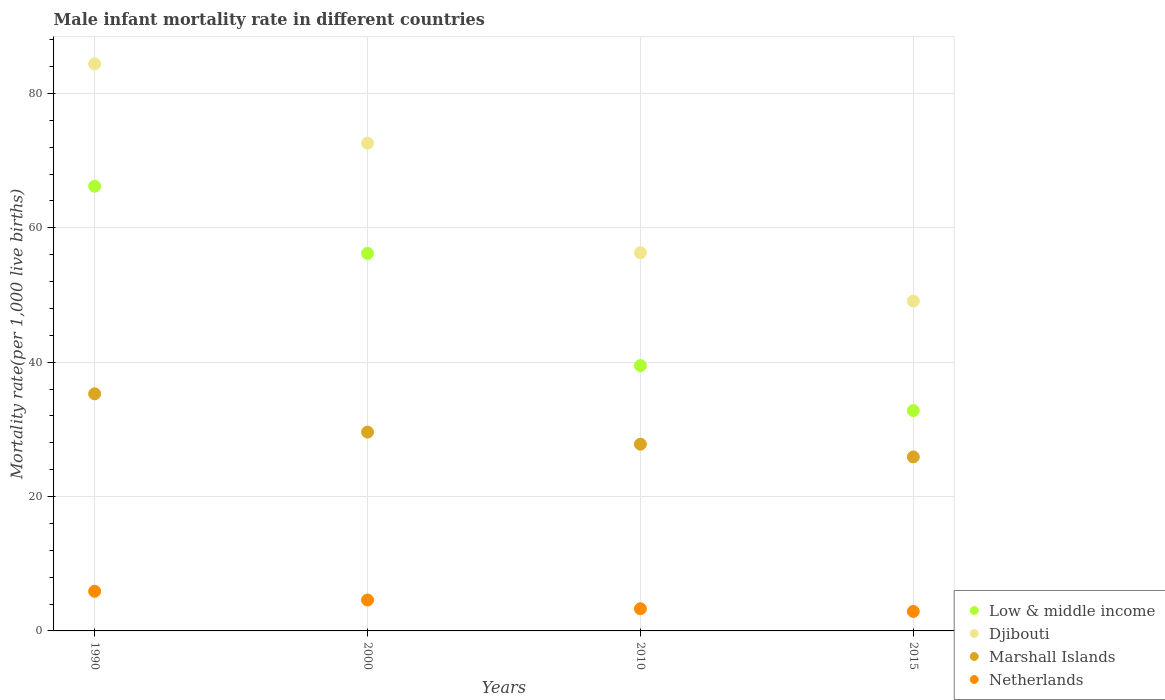How many different coloured dotlines are there?
Give a very brief answer. 4. Is the number of dotlines equal to the number of legend labels?
Offer a very short reply. Yes. What is the male infant mortality rate in Djibouti in 1990?
Offer a very short reply. 84.4. Across all years, what is the maximum male infant mortality rate in Djibouti?
Your answer should be very brief. 84.4. Across all years, what is the minimum male infant mortality rate in Marshall Islands?
Your response must be concise. 25.9. In which year was the male infant mortality rate in Low & middle income maximum?
Ensure brevity in your answer.  1990. In which year was the male infant mortality rate in Low & middle income minimum?
Offer a very short reply. 2015. What is the difference between the male infant mortality rate in Netherlands in 1990 and that in 2000?
Your answer should be compact. 1.3. What is the difference between the male infant mortality rate in Marshall Islands in 1990 and the male infant mortality rate in Netherlands in 2000?
Ensure brevity in your answer.  30.7. What is the average male infant mortality rate in Djibouti per year?
Give a very brief answer. 65.6. In the year 2010, what is the difference between the male infant mortality rate in Marshall Islands and male infant mortality rate in Netherlands?
Your response must be concise. 24.5. What is the ratio of the male infant mortality rate in Low & middle income in 2010 to that in 2015?
Make the answer very short. 1.2. Is the male infant mortality rate in Low & middle income in 1990 less than that in 2010?
Your answer should be very brief. No. Is the difference between the male infant mortality rate in Marshall Islands in 1990 and 2010 greater than the difference between the male infant mortality rate in Netherlands in 1990 and 2010?
Your answer should be very brief. Yes. What is the difference between the highest and the second highest male infant mortality rate in Netherlands?
Offer a terse response. 1.3. What is the difference between the highest and the lowest male infant mortality rate in Low & middle income?
Ensure brevity in your answer.  33.4. Is it the case that in every year, the sum of the male infant mortality rate in Netherlands and male infant mortality rate in Low & middle income  is greater than the sum of male infant mortality rate in Marshall Islands and male infant mortality rate in Djibouti?
Your answer should be compact. Yes. Is it the case that in every year, the sum of the male infant mortality rate in Netherlands and male infant mortality rate in Low & middle income  is greater than the male infant mortality rate in Marshall Islands?
Make the answer very short. Yes. Does the male infant mortality rate in Djibouti monotonically increase over the years?
Provide a short and direct response. No. How many dotlines are there?
Give a very brief answer. 4. What is the difference between two consecutive major ticks on the Y-axis?
Provide a succinct answer. 20. Are the values on the major ticks of Y-axis written in scientific E-notation?
Offer a very short reply. No. Does the graph contain any zero values?
Make the answer very short. No. Where does the legend appear in the graph?
Give a very brief answer. Bottom right. How many legend labels are there?
Make the answer very short. 4. How are the legend labels stacked?
Offer a very short reply. Vertical. What is the title of the graph?
Make the answer very short. Male infant mortality rate in different countries. What is the label or title of the X-axis?
Your answer should be very brief. Years. What is the label or title of the Y-axis?
Keep it short and to the point. Mortality rate(per 1,0 live births). What is the Mortality rate(per 1,000 live births) in Low & middle income in 1990?
Offer a terse response. 66.2. What is the Mortality rate(per 1,000 live births) of Djibouti in 1990?
Offer a terse response. 84.4. What is the Mortality rate(per 1,000 live births) of Marshall Islands in 1990?
Your answer should be compact. 35.3. What is the Mortality rate(per 1,000 live births) in Netherlands in 1990?
Provide a succinct answer. 5.9. What is the Mortality rate(per 1,000 live births) of Low & middle income in 2000?
Give a very brief answer. 56.2. What is the Mortality rate(per 1,000 live births) in Djibouti in 2000?
Your answer should be compact. 72.6. What is the Mortality rate(per 1,000 live births) of Marshall Islands in 2000?
Offer a very short reply. 29.6. What is the Mortality rate(per 1,000 live births) of Netherlands in 2000?
Keep it short and to the point. 4.6. What is the Mortality rate(per 1,000 live births) of Low & middle income in 2010?
Offer a very short reply. 39.5. What is the Mortality rate(per 1,000 live births) of Djibouti in 2010?
Provide a succinct answer. 56.3. What is the Mortality rate(per 1,000 live births) in Marshall Islands in 2010?
Provide a succinct answer. 27.8. What is the Mortality rate(per 1,000 live births) in Netherlands in 2010?
Keep it short and to the point. 3.3. What is the Mortality rate(per 1,000 live births) of Low & middle income in 2015?
Offer a very short reply. 32.8. What is the Mortality rate(per 1,000 live births) of Djibouti in 2015?
Make the answer very short. 49.1. What is the Mortality rate(per 1,000 live births) in Marshall Islands in 2015?
Your answer should be compact. 25.9. Across all years, what is the maximum Mortality rate(per 1,000 live births) in Low & middle income?
Your answer should be very brief. 66.2. Across all years, what is the maximum Mortality rate(per 1,000 live births) of Djibouti?
Your answer should be compact. 84.4. Across all years, what is the maximum Mortality rate(per 1,000 live births) in Marshall Islands?
Your answer should be very brief. 35.3. Across all years, what is the maximum Mortality rate(per 1,000 live births) of Netherlands?
Your answer should be compact. 5.9. Across all years, what is the minimum Mortality rate(per 1,000 live births) in Low & middle income?
Offer a very short reply. 32.8. Across all years, what is the minimum Mortality rate(per 1,000 live births) of Djibouti?
Your answer should be compact. 49.1. Across all years, what is the minimum Mortality rate(per 1,000 live births) of Marshall Islands?
Make the answer very short. 25.9. Across all years, what is the minimum Mortality rate(per 1,000 live births) of Netherlands?
Your answer should be compact. 2.9. What is the total Mortality rate(per 1,000 live births) of Low & middle income in the graph?
Offer a very short reply. 194.7. What is the total Mortality rate(per 1,000 live births) of Djibouti in the graph?
Your response must be concise. 262.4. What is the total Mortality rate(per 1,000 live births) of Marshall Islands in the graph?
Provide a short and direct response. 118.6. What is the total Mortality rate(per 1,000 live births) of Netherlands in the graph?
Your answer should be very brief. 16.7. What is the difference between the Mortality rate(per 1,000 live births) in Djibouti in 1990 and that in 2000?
Give a very brief answer. 11.8. What is the difference between the Mortality rate(per 1,000 live births) of Low & middle income in 1990 and that in 2010?
Offer a terse response. 26.7. What is the difference between the Mortality rate(per 1,000 live births) in Djibouti in 1990 and that in 2010?
Provide a succinct answer. 28.1. What is the difference between the Mortality rate(per 1,000 live births) in Marshall Islands in 1990 and that in 2010?
Ensure brevity in your answer.  7.5. What is the difference between the Mortality rate(per 1,000 live births) in Low & middle income in 1990 and that in 2015?
Keep it short and to the point. 33.4. What is the difference between the Mortality rate(per 1,000 live births) of Djibouti in 1990 and that in 2015?
Provide a succinct answer. 35.3. What is the difference between the Mortality rate(per 1,000 live births) of Marshall Islands in 1990 and that in 2015?
Provide a short and direct response. 9.4. What is the difference between the Mortality rate(per 1,000 live births) of Netherlands in 1990 and that in 2015?
Give a very brief answer. 3. What is the difference between the Mortality rate(per 1,000 live births) of Marshall Islands in 2000 and that in 2010?
Your answer should be very brief. 1.8. What is the difference between the Mortality rate(per 1,000 live births) of Low & middle income in 2000 and that in 2015?
Offer a terse response. 23.4. What is the difference between the Mortality rate(per 1,000 live births) of Djibouti in 2000 and that in 2015?
Your answer should be compact. 23.5. What is the difference between the Mortality rate(per 1,000 live births) in Low & middle income in 2010 and that in 2015?
Keep it short and to the point. 6.7. What is the difference between the Mortality rate(per 1,000 live births) of Djibouti in 2010 and that in 2015?
Give a very brief answer. 7.2. What is the difference between the Mortality rate(per 1,000 live births) in Netherlands in 2010 and that in 2015?
Offer a very short reply. 0.4. What is the difference between the Mortality rate(per 1,000 live births) of Low & middle income in 1990 and the Mortality rate(per 1,000 live births) of Djibouti in 2000?
Give a very brief answer. -6.4. What is the difference between the Mortality rate(per 1,000 live births) of Low & middle income in 1990 and the Mortality rate(per 1,000 live births) of Marshall Islands in 2000?
Keep it short and to the point. 36.6. What is the difference between the Mortality rate(per 1,000 live births) of Low & middle income in 1990 and the Mortality rate(per 1,000 live births) of Netherlands in 2000?
Give a very brief answer. 61.6. What is the difference between the Mortality rate(per 1,000 live births) of Djibouti in 1990 and the Mortality rate(per 1,000 live births) of Marshall Islands in 2000?
Make the answer very short. 54.8. What is the difference between the Mortality rate(per 1,000 live births) of Djibouti in 1990 and the Mortality rate(per 1,000 live births) of Netherlands in 2000?
Make the answer very short. 79.8. What is the difference between the Mortality rate(per 1,000 live births) of Marshall Islands in 1990 and the Mortality rate(per 1,000 live births) of Netherlands in 2000?
Keep it short and to the point. 30.7. What is the difference between the Mortality rate(per 1,000 live births) in Low & middle income in 1990 and the Mortality rate(per 1,000 live births) in Marshall Islands in 2010?
Make the answer very short. 38.4. What is the difference between the Mortality rate(per 1,000 live births) of Low & middle income in 1990 and the Mortality rate(per 1,000 live births) of Netherlands in 2010?
Your answer should be very brief. 62.9. What is the difference between the Mortality rate(per 1,000 live births) in Djibouti in 1990 and the Mortality rate(per 1,000 live births) in Marshall Islands in 2010?
Keep it short and to the point. 56.6. What is the difference between the Mortality rate(per 1,000 live births) in Djibouti in 1990 and the Mortality rate(per 1,000 live births) in Netherlands in 2010?
Provide a short and direct response. 81.1. What is the difference between the Mortality rate(per 1,000 live births) in Low & middle income in 1990 and the Mortality rate(per 1,000 live births) in Marshall Islands in 2015?
Provide a succinct answer. 40.3. What is the difference between the Mortality rate(per 1,000 live births) of Low & middle income in 1990 and the Mortality rate(per 1,000 live births) of Netherlands in 2015?
Your response must be concise. 63.3. What is the difference between the Mortality rate(per 1,000 live births) of Djibouti in 1990 and the Mortality rate(per 1,000 live births) of Marshall Islands in 2015?
Give a very brief answer. 58.5. What is the difference between the Mortality rate(per 1,000 live births) in Djibouti in 1990 and the Mortality rate(per 1,000 live births) in Netherlands in 2015?
Give a very brief answer. 81.5. What is the difference between the Mortality rate(per 1,000 live births) in Marshall Islands in 1990 and the Mortality rate(per 1,000 live births) in Netherlands in 2015?
Keep it short and to the point. 32.4. What is the difference between the Mortality rate(per 1,000 live births) in Low & middle income in 2000 and the Mortality rate(per 1,000 live births) in Marshall Islands in 2010?
Provide a succinct answer. 28.4. What is the difference between the Mortality rate(per 1,000 live births) of Low & middle income in 2000 and the Mortality rate(per 1,000 live births) of Netherlands in 2010?
Ensure brevity in your answer.  52.9. What is the difference between the Mortality rate(per 1,000 live births) of Djibouti in 2000 and the Mortality rate(per 1,000 live births) of Marshall Islands in 2010?
Offer a very short reply. 44.8. What is the difference between the Mortality rate(per 1,000 live births) of Djibouti in 2000 and the Mortality rate(per 1,000 live births) of Netherlands in 2010?
Your answer should be compact. 69.3. What is the difference between the Mortality rate(per 1,000 live births) in Marshall Islands in 2000 and the Mortality rate(per 1,000 live births) in Netherlands in 2010?
Ensure brevity in your answer.  26.3. What is the difference between the Mortality rate(per 1,000 live births) of Low & middle income in 2000 and the Mortality rate(per 1,000 live births) of Marshall Islands in 2015?
Keep it short and to the point. 30.3. What is the difference between the Mortality rate(per 1,000 live births) in Low & middle income in 2000 and the Mortality rate(per 1,000 live births) in Netherlands in 2015?
Keep it short and to the point. 53.3. What is the difference between the Mortality rate(per 1,000 live births) of Djibouti in 2000 and the Mortality rate(per 1,000 live births) of Marshall Islands in 2015?
Provide a short and direct response. 46.7. What is the difference between the Mortality rate(per 1,000 live births) of Djibouti in 2000 and the Mortality rate(per 1,000 live births) of Netherlands in 2015?
Give a very brief answer. 69.7. What is the difference between the Mortality rate(per 1,000 live births) in Marshall Islands in 2000 and the Mortality rate(per 1,000 live births) in Netherlands in 2015?
Keep it short and to the point. 26.7. What is the difference between the Mortality rate(per 1,000 live births) in Low & middle income in 2010 and the Mortality rate(per 1,000 live births) in Djibouti in 2015?
Make the answer very short. -9.6. What is the difference between the Mortality rate(per 1,000 live births) in Low & middle income in 2010 and the Mortality rate(per 1,000 live births) in Netherlands in 2015?
Provide a short and direct response. 36.6. What is the difference between the Mortality rate(per 1,000 live births) of Djibouti in 2010 and the Mortality rate(per 1,000 live births) of Marshall Islands in 2015?
Your answer should be compact. 30.4. What is the difference between the Mortality rate(per 1,000 live births) of Djibouti in 2010 and the Mortality rate(per 1,000 live births) of Netherlands in 2015?
Offer a terse response. 53.4. What is the difference between the Mortality rate(per 1,000 live births) in Marshall Islands in 2010 and the Mortality rate(per 1,000 live births) in Netherlands in 2015?
Provide a short and direct response. 24.9. What is the average Mortality rate(per 1,000 live births) in Low & middle income per year?
Ensure brevity in your answer.  48.67. What is the average Mortality rate(per 1,000 live births) of Djibouti per year?
Offer a terse response. 65.6. What is the average Mortality rate(per 1,000 live births) of Marshall Islands per year?
Offer a very short reply. 29.65. What is the average Mortality rate(per 1,000 live births) in Netherlands per year?
Provide a succinct answer. 4.17. In the year 1990, what is the difference between the Mortality rate(per 1,000 live births) in Low & middle income and Mortality rate(per 1,000 live births) in Djibouti?
Make the answer very short. -18.2. In the year 1990, what is the difference between the Mortality rate(per 1,000 live births) in Low & middle income and Mortality rate(per 1,000 live births) in Marshall Islands?
Ensure brevity in your answer.  30.9. In the year 1990, what is the difference between the Mortality rate(per 1,000 live births) of Low & middle income and Mortality rate(per 1,000 live births) of Netherlands?
Your answer should be very brief. 60.3. In the year 1990, what is the difference between the Mortality rate(per 1,000 live births) of Djibouti and Mortality rate(per 1,000 live births) of Marshall Islands?
Your answer should be compact. 49.1. In the year 1990, what is the difference between the Mortality rate(per 1,000 live births) in Djibouti and Mortality rate(per 1,000 live births) in Netherlands?
Provide a short and direct response. 78.5. In the year 1990, what is the difference between the Mortality rate(per 1,000 live births) of Marshall Islands and Mortality rate(per 1,000 live births) of Netherlands?
Offer a terse response. 29.4. In the year 2000, what is the difference between the Mortality rate(per 1,000 live births) of Low & middle income and Mortality rate(per 1,000 live births) of Djibouti?
Provide a succinct answer. -16.4. In the year 2000, what is the difference between the Mortality rate(per 1,000 live births) in Low & middle income and Mortality rate(per 1,000 live births) in Marshall Islands?
Give a very brief answer. 26.6. In the year 2000, what is the difference between the Mortality rate(per 1,000 live births) of Low & middle income and Mortality rate(per 1,000 live births) of Netherlands?
Make the answer very short. 51.6. In the year 2000, what is the difference between the Mortality rate(per 1,000 live births) of Djibouti and Mortality rate(per 1,000 live births) of Netherlands?
Offer a terse response. 68. In the year 2000, what is the difference between the Mortality rate(per 1,000 live births) in Marshall Islands and Mortality rate(per 1,000 live births) in Netherlands?
Ensure brevity in your answer.  25. In the year 2010, what is the difference between the Mortality rate(per 1,000 live births) of Low & middle income and Mortality rate(per 1,000 live births) of Djibouti?
Keep it short and to the point. -16.8. In the year 2010, what is the difference between the Mortality rate(per 1,000 live births) in Low & middle income and Mortality rate(per 1,000 live births) in Marshall Islands?
Keep it short and to the point. 11.7. In the year 2010, what is the difference between the Mortality rate(per 1,000 live births) in Low & middle income and Mortality rate(per 1,000 live births) in Netherlands?
Give a very brief answer. 36.2. In the year 2010, what is the difference between the Mortality rate(per 1,000 live births) of Djibouti and Mortality rate(per 1,000 live births) of Marshall Islands?
Provide a short and direct response. 28.5. In the year 2010, what is the difference between the Mortality rate(per 1,000 live births) of Djibouti and Mortality rate(per 1,000 live births) of Netherlands?
Keep it short and to the point. 53. In the year 2015, what is the difference between the Mortality rate(per 1,000 live births) in Low & middle income and Mortality rate(per 1,000 live births) in Djibouti?
Your answer should be compact. -16.3. In the year 2015, what is the difference between the Mortality rate(per 1,000 live births) of Low & middle income and Mortality rate(per 1,000 live births) of Netherlands?
Your response must be concise. 29.9. In the year 2015, what is the difference between the Mortality rate(per 1,000 live births) in Djibouti and Mortality rate(per 1,000 live births) in Marshall Islands?
Your answer should be compact. 23.2. In the year 2015, what is the difference between the Mortality rate(per 1,000 live births) of Djibouti and Mortality rate(per 1,000 live births) of Netherlands?
Your answer should be very brief. 46.2. What is the ratio of the Mortality rate(per 1,000 live births) of Low & middle income in 1990 to that in 2000?
Ensure brevity in your answer.  1.18. What is the ratio of the Mortality rate(per 1,000 live births) of Djibouti in 1990 to that in 2000?
Provide a short and direct response. 1.16. What is the ratio of the Mortality rate(per 1,000 live births) of Marshall Islands in 1990 to that in 2000?
Your response must be concise. 1.19. What is the ratio of the Mortality rate(per 1,000 live births) in Netherlands in 1990 to that in 2000?
Give a very brief answer. 1.28. What is the ratio of the Mortality rate(per 1,000 live births) of Low & middle income in 1990 to that in 2010?
Ensure brevity in your answer.  1.68. What is the ratio of the Mortality rate(per 1,000 live births) of Djibouti in 1990 to that in 2010?
Ensure brevity in your answer.  1.5. What is the ratio of the Mortality rate(per 1,000 live births) in Marshall Islands in 1990 to that in 2010?
Make the answer very short. 1.27. What is the ratio of the Mortality rate(per 1,000 live births) in Netherlands in 1990 to that in 2010?
Offer a terse response. 1.79. What is the ratio of the Mortality rate(per 1,000 live births) of Low & middle income in 1990 to that in 2015?
Provide a short and direct response. 2.02. What is the ratio of the Mortality rate(per 1,000 live births) in Djibouti in 1990 to that in 2015?
Provide a short and direct response. 1.72. What is the ratio of the Mortality rate(per 1,000 live births) of Marshall Islands in 1990 to that in 2015?
Your answer should be compact. 1.36. What is the ratio of the Mortality rate(per 1,000 live births) in Netherlands in 1990 to that in 2015?
Your answer should be very brief. 2.03. What is the ratio of the Mortality rate(per 1,000 live births) in Low & middle income in 2000 to that in 2010?
Offer a terse response. 1.42. What is the ratio of the Mortality rate(per 1,000 live births) in Djibouti in 2000 to that in 2010?
Your answer should be very brief. 1.29. What is the ratio of the Mortality rate(per 1,000 live births) in Marshall Islands in 2000 to that in 2010?
Your answer should be compact. 1.06. What is the ratio of the Mortality rate(per 1,000 live births) in Netherlands in 2000 to that in 2010?
Offer a terse response. 1.39. What is the ratio of the Mortality rate(per 1,000 live births) of Low & middle income in 2000 to that in 2015?
Offer a terse response. 1.71. What is the ratio of the Mortality rate(per 1,000 live births) of Djibouti in 2000 to that in 2015?
Provide a succinct answer. 1.48. What is the ratio of the Mortality rate(per 1,000 live births) in Marshall Islands in 2000 to that in 2015?
Ensure brevity in your answer.  1.14. What is the ratio of the Mortality rate(per 1,000 live births) of Netherlands in 2000 to that in 2015?
Give a very brief answer. 1.59. What is the ratio of the Mortality rate(per 1,000 live births) in Low & middle income in 2010 to that in 2015?
Your response must be concise. 1.2. What is the ratio of the Mortality rate(per 1,000 live births) in Djibouti in 2010 to that in 2015?
Make the answer very short. 1.15. What is the ratio of the Mortality rate(per 1,000 live births) in Marshall Islands in 2010 to that in 2015?
Provide a short and direct response. 1.07. What is the ratio of the Mortality rate(per 1,000 live births) in Netherlands in 2010 to that in 2015?
Offer a terse response. 1.14. What is the difference between the highest and the second highest Mortality rate(per 1,000 live births) of Low & middle income?
Ensure brevity in your answer.  10. What is the difference between the highest and the second highest Mortality rate(per 1,000 live births) of Djibouti?
Keep it short and to the point. 11.8. What is the difference between the highest and the second highest Mortality rate(per 1,000 live births) in Marshall Islands?
Provide a short and direct response. 5.7. What is the difference between the highest and the second highest Mortality rate(per 1,000 live births) of Netherlands?
Your answer should be very brief. 1.3. What is the difference between the highest and the lowest Mortality rate(per 1,000 live births) in Low & middle income?
Provide a short and direct response. 33.4. What is the difference between the highest and the lowest Mortality rate(per 1,000 live births) of Djibouti?
Provide a succinct answer. 35.3. What is the difference between the highest and the lowest Mortality rate(per 1,000 live births) of Marshall Islands?
Make the answer very short. 9.4. What is the difference between the highest and the lowest Mortality rate(per 1,000 live births) in Netherlands?
Your answer should be very brief. 3. 